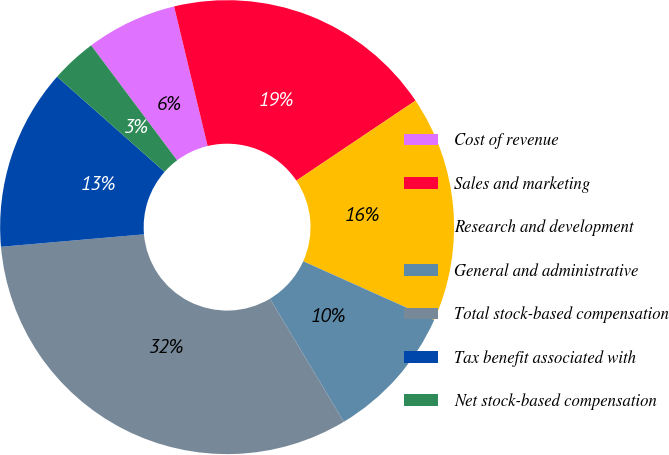Convert chart. <chart><loc_0><loc_0><loc_500><loc_500><pie_chart><fcel>Cost of revenue<fcel>Sales and marketing<fcel>Research and development<fcel>General and administrative<fcel>Total stock-based compensation<fcel>Tax benefit associated with<fcel>Net stock-based compensation<nl><fcel>6.47%<fcel>19.34%<fcel>16.12%<fcel>9.69%<fcel>32.22%<fcel>12.91%<fcel>3.25%<nl></chart> 